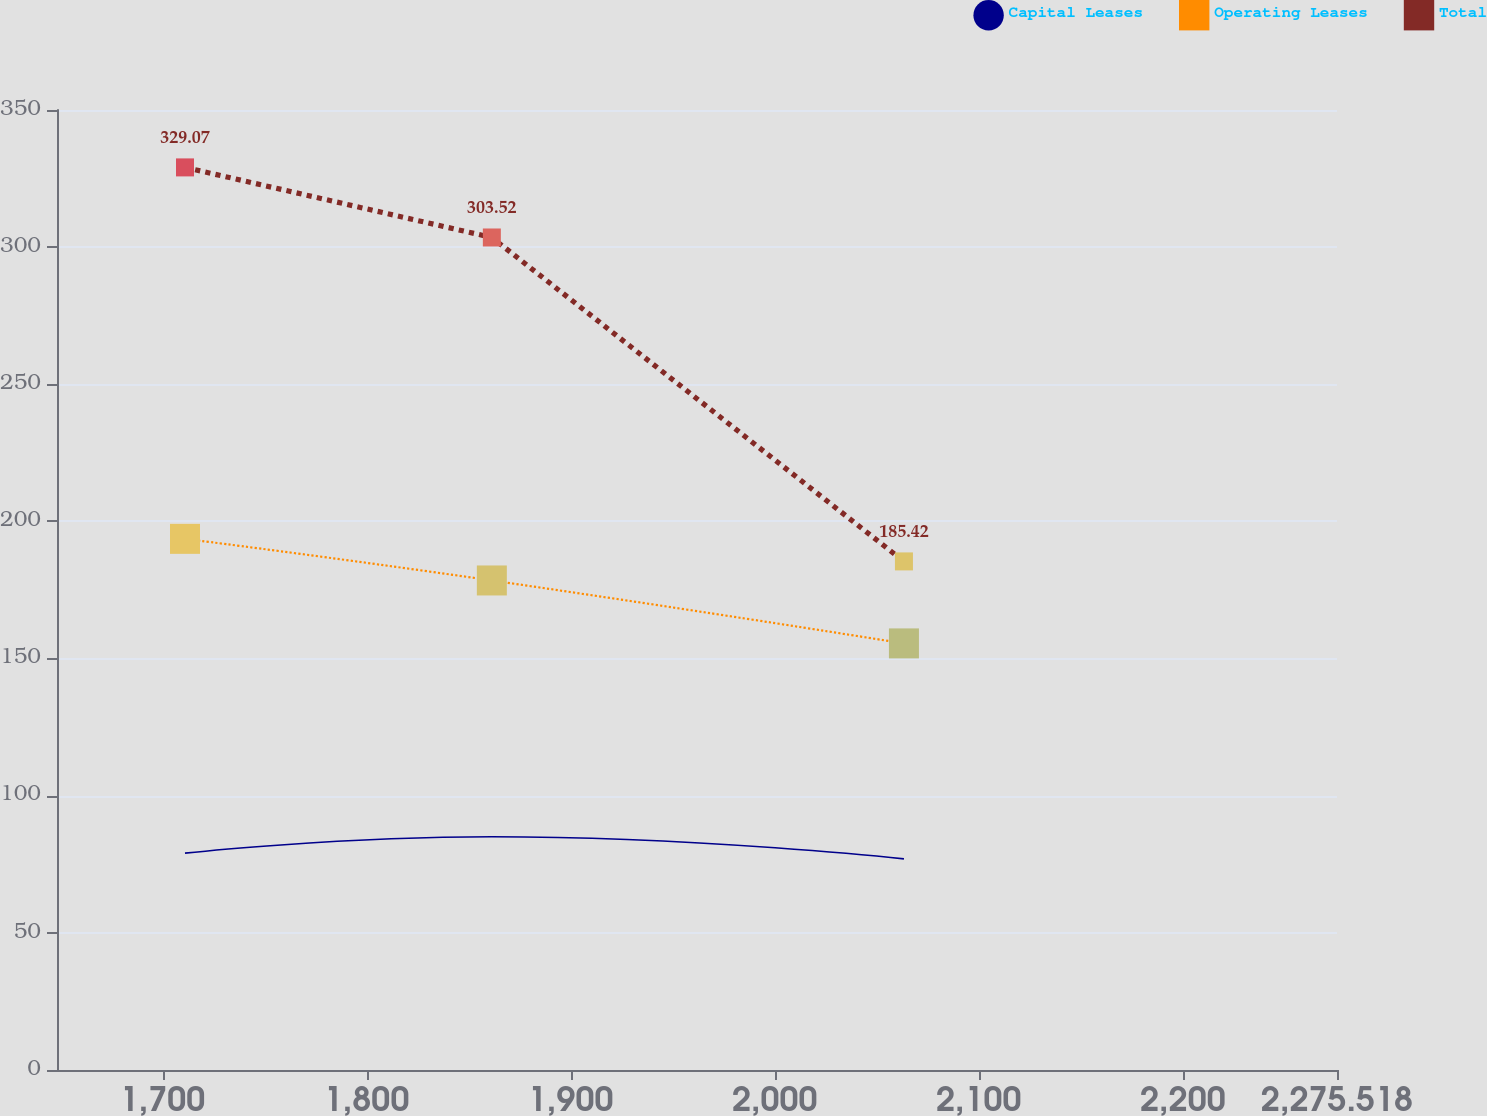<chart> <loc_0><loc_0><loc_500><loc_500><line_chart><ecel><fcel>Capital Leases<fcel>Operating Leases<fcel>Total<nl><fcel>1711.02<fcel>79.07<fcel>193.65<fcel>329.07<nl><fcel>1861.38<fcel>85.04<fcel>178.47<fcel>303.52<nl><fcel>2063.31<fcel>76.97<fcel>155.53<fcel>185.42<nl><fcel>2280.74<fcel>64.03<fcel>107.29<fcel>208.23<nl><fcel>2338.24<fcel>81.17<fcel>95.33<fcel>159.44<nl></chart> 